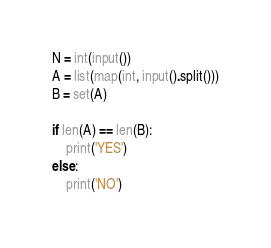<code> <loc_0><loc_0><loc_500><loc_500><_Python_>N = int(input())
A = list(map(int, input().split()))
B = set(A)

if len(A) == len(B):
    print('YES')
else:
    print('NO')</code> 